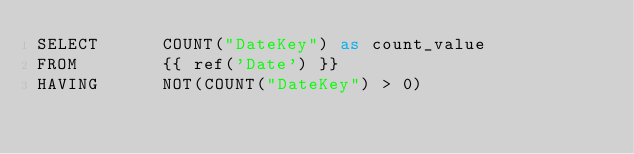<code> <loc_0><loc_0><loc_500><loc_500><_SQL_>SELECT      COUNT("DateKey") as count_value
FROM        {{ ref('Date') }}
HAVING      NOT(COUNT("DateKey") > 0)</code> 